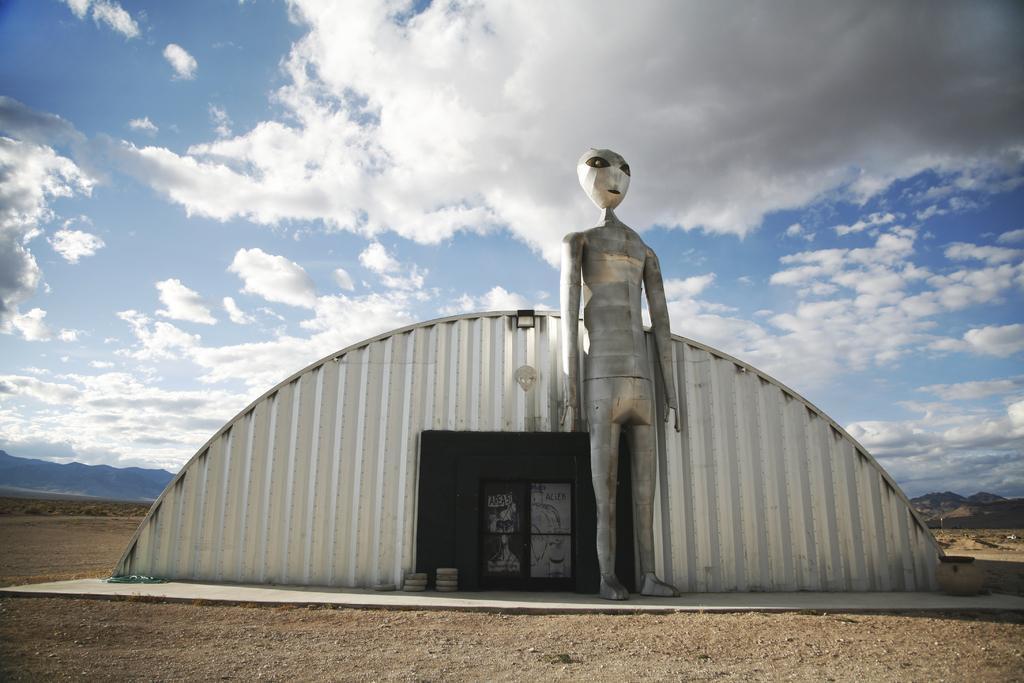In one or two sentences, can you explain what this image depicts? In this image I can see the ground, a shed which is made up of metal and in front of the shed I can see a metal statue which is silver in color. In the background I can see few mountains and the sky. 